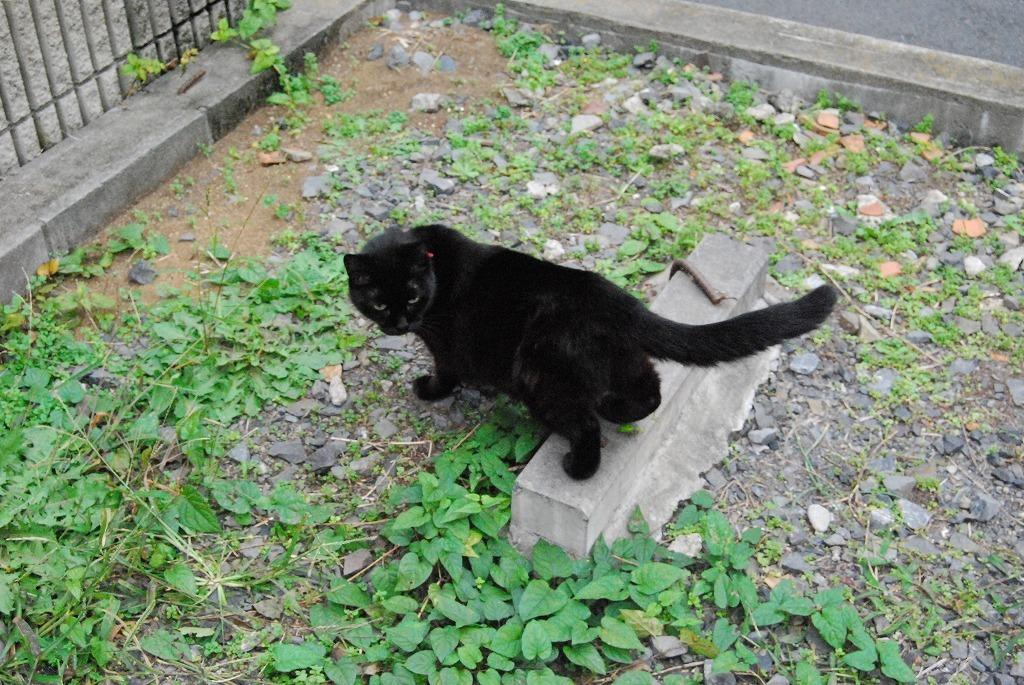What type of living organisms can be seen in the image? Plants can be seen in the image. What animal is located in the middle of the image? There is a black cat in the middle of the image. Where are the grills situated in the image? The grills are in the top left of the image. What type of floor can be seen in the image? There is no floor visible in the image; it appears to be a close-up of the plants, cat, and grills. Is there a hospital present in the image? No, there is no hospital present in the image. 